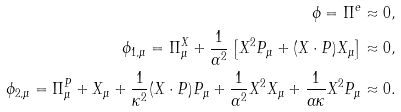Convert formula to latex. <formula><loc_0><loc_0><loc_500><loc_500>\phi = \Pi ^ { e } \approx 0 , \\ \phi _ { 1 , \mu } = \Pi ^ { X } _ { \mu } + \frac { 1 } { \alpha ^ { 2 } } \left [ X ^ { 2 } P _ { \mu } + ( X \cdot P ) X _ { \mu } \right ] \approx 0 , \\ \phi _ { 2 , \mu } = \Pi ^ { P } _ { \mu } + X _ { \mu } + \frac { 1 } { \kappa ^ { 2 } } ( X \cdot P ) P _ { \mu } + \frac { 1 } { \alpha ^ { 2 } } X ^ { 2 } X _ { \mu } + \frac { 1 } { \alpha \kappa } X ^ { 2 } P _ { \mu } \approx 0 .</formula> 